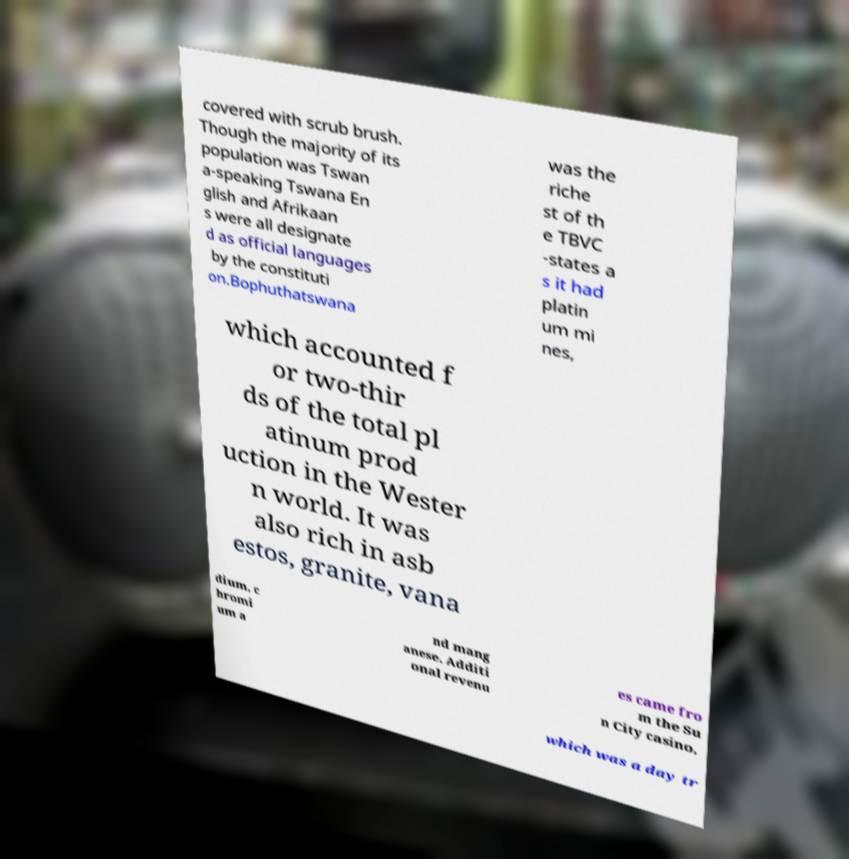Can you accurately transcribe the text from the provided image for me? covered with scrub brush. Though the majority of its population was Tswan a-speaking Tswana En glish and Afrikaan s were all designate d as official languages by the constituti on.Bophuthatswana was the riche st of th e TBVC -states a s it had platin um mi nes, which accounted f or two-thir ds of the total pl atinum prod uction in the Wester n world. It was also rich in asb estos, granite, vana dium, c hromi um a nd mang anese. Additi onal revenu es came fro m the Su n City casino, which was a day tr 